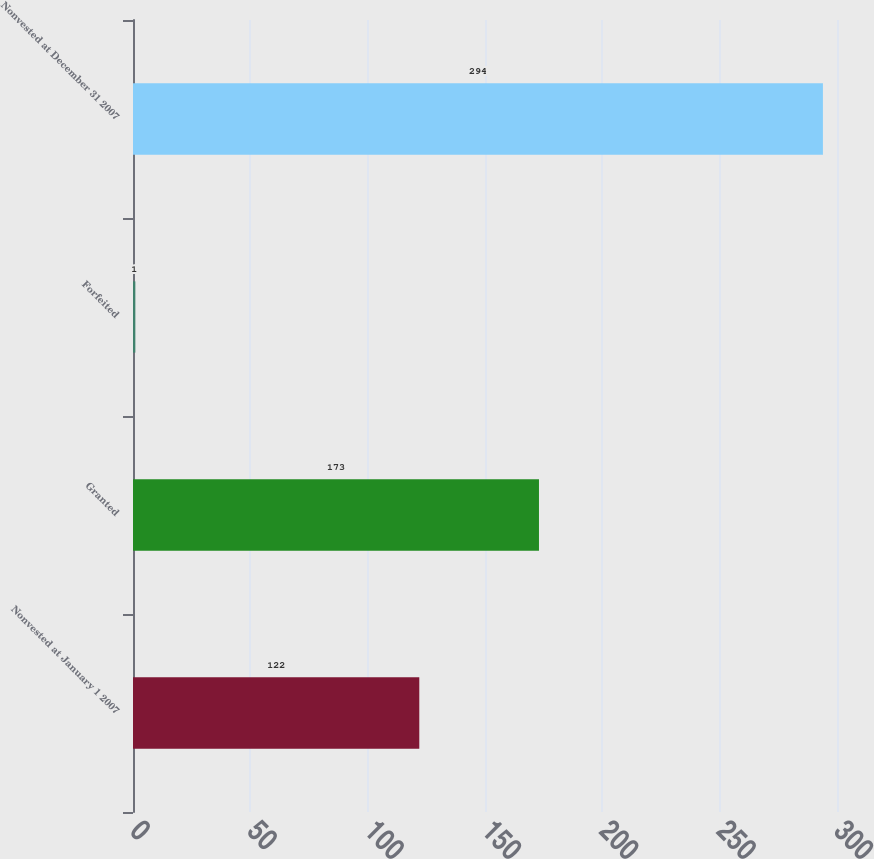<chart> <loc_0><loc_0><loc_500><loc_500><bar_chart><fcel>Nonvested at January 1 2007<fcel>Granted<fcel>Forfeited<fcel>Nonvested at December 31 2007<nl><fcel>122<fcel>173<fcel>1<fcel>294<nl></chart> 